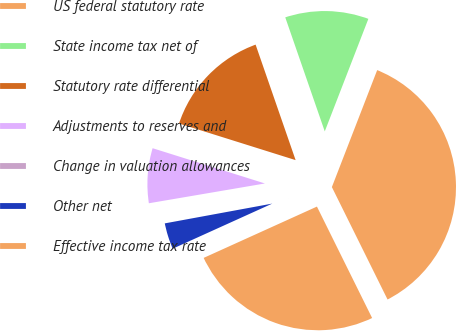<chart> <loc_0><loc_0><loc_500><loc_500><pie_chart><fcel>US federal statutory rate<fcel>State income tax net of<fcel>Statutory rate differential<fcel>Adjustments to reserves and<fcel>Change in valuation allowances<fcel>Other net<fcel>Effective income tax rate<nl><fcel>36.8%<fcel>11.19%<fcel>14.85%<fcel>7.53%<fcel>0.21%<fcel>3.87%<fcel>25.55%<nl></chart> 